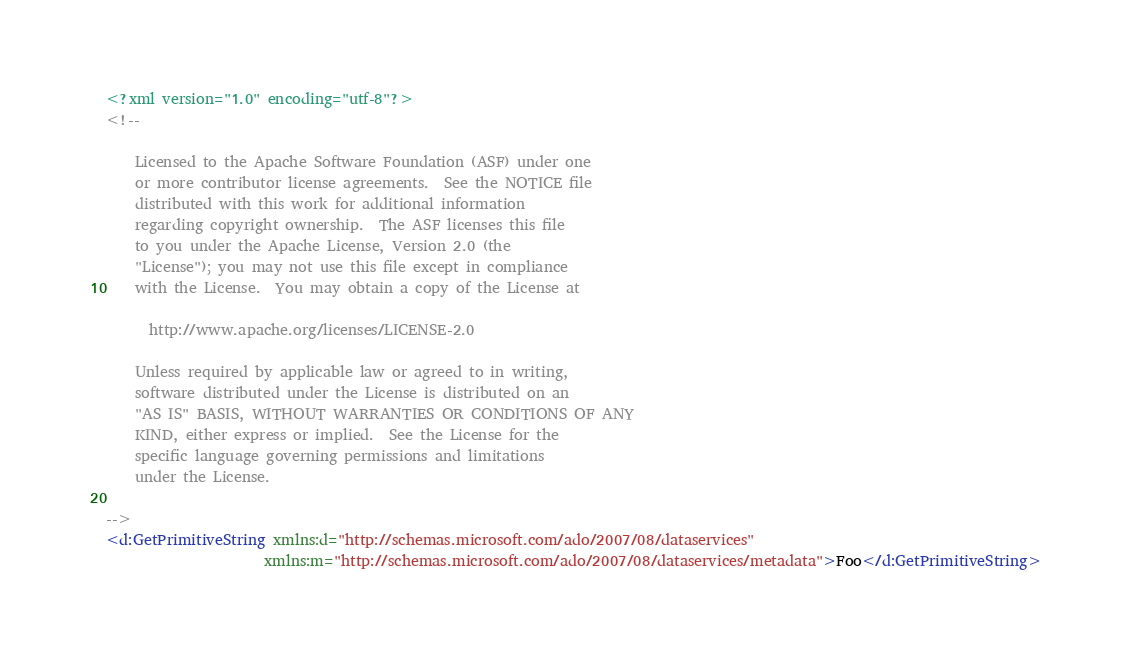<code> <loc_0><loc_0><loc_500><loc_500><_XML_><?xml version="1.0" encoding="utf-8"?>
<!--

    Licensed to the Apache Software Foundation (ASF) under one
    or more contributor license agreements.  See the NOTICE file
    distributed with this work for additional information
    regarding copyright ownership.  The ASF licenses this file
    to you under the Apache License, Version 2.0 (the
    "License"); you may not use this file except in compliance
    with the License.  You may obtain a copy of the License at

      http://www.apache.org/licenses/LICENSE-2.0

    Unless required by applicable law or agreed to in writing,
    software distributed under the License is distributed on an
    "AS IS" BASIS, WITHOUT WARRANTIES OR CONDITIONS OF ANY
    KIND, either express or implied.  See the License for the
    specific language governing permissions and limitations
    under the License.

-->
<d:GetPrimitiveString xmlns:d="http://schemas.microsoft.com/ado/2007/08/dataservices" 
                      xmlns:m="http://schemas.microsoft.com/ado/2007/08/dataservices/metadata">Foo</d:GetPrimitiveString>
</code> 